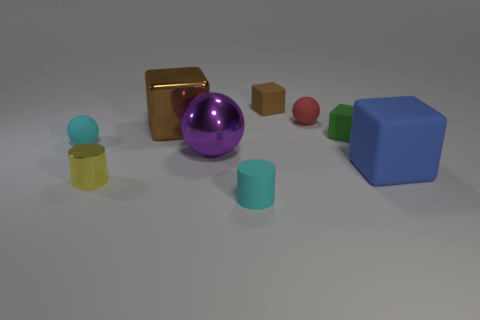There is a small thing that is the same color as the big shiny cube; what material is it?
Provide a succinct answer. Rubber. What number of large things are yellow shiny cylinders or yellow rubber things?
Provide a short and direct response. 0. There is a small cyan thing on the left side of the matte cylinder; what is its shape?
Keep it short and to the point. Sphere. Is there a ball that has the same color as the metallic block?
Your answer should be very brief. No. Does the cyan matte thing behind the large matte object have the same size as the cube left of the metal sphere?
Ensure brevity in your answer.  No. Is the number of purple balls that are in front of the blue cube greater than the number of large blue things that are left of the tiny yellow object?
Offer a terse response. No. Is there a big red ball that has the same material as the tiny yellow cylinder?
Give a very brief answer. No. Is the large ball the same color as the large matte object?
Your answer should be compact. No. What is the ball that is on the right side of the small yellow thing and on the left side of the small red object made of?
Make the answer very short. Metal. The metallic ball has what color?
Make the answer very short. Purple. 